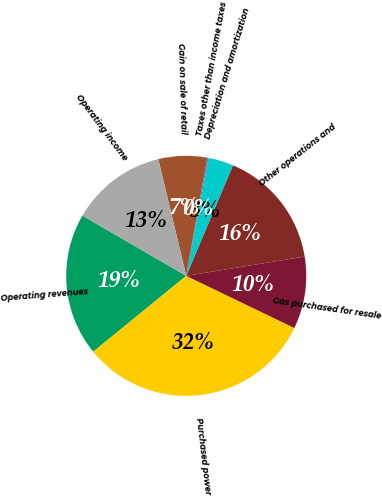Convert chart. <chart><loc_0><loc_0><loc_500><loc_500><pie_chart><fcel>Operating revenues<fcel>Purchased power<fcel>Gas purchased for resale<fcel>Other operations and<fcel>Depreciation and amortization<fcel>Taxes other than income taxes<fcel>Gain on sale of retail<fcel>Operating income<nl><fcel>19.25%<fcel>31.96%<fcel>9.72%<fcel>16.07%<fcel>3.37%<fcel>0.19%<fcel>6.54%<fcel>12.9%<nl></chart> 